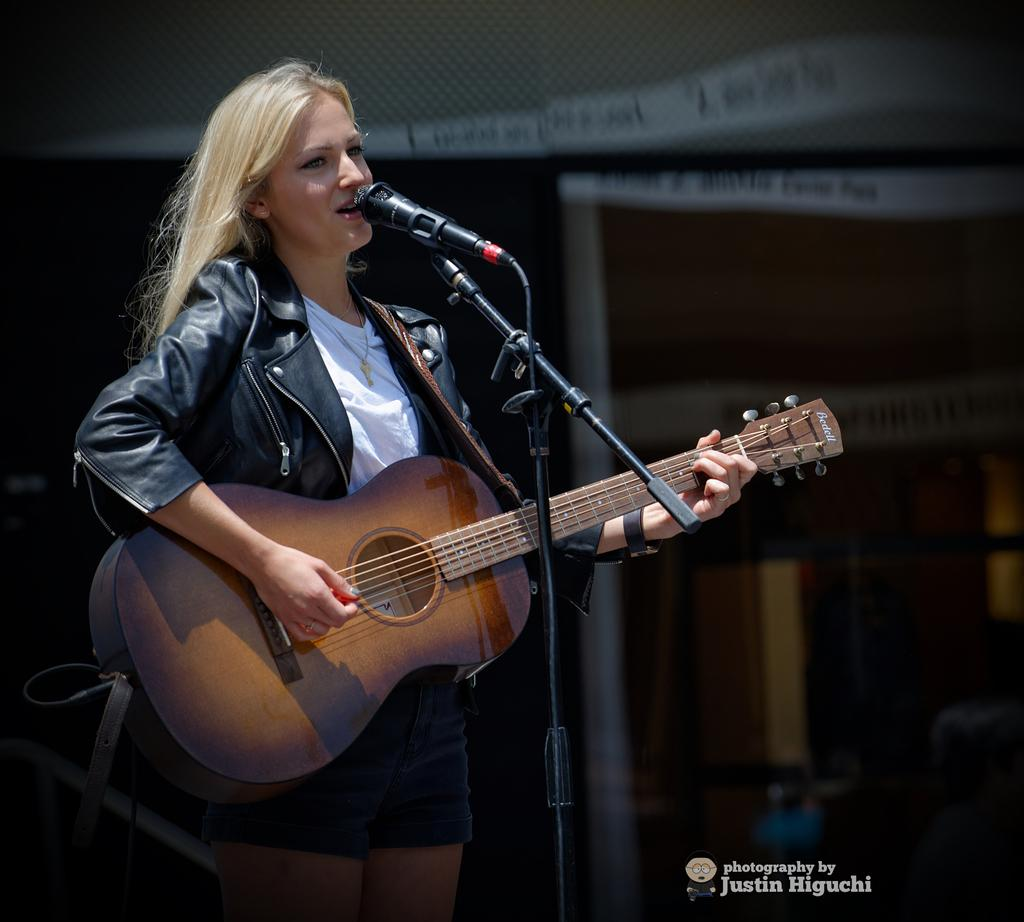Who is the main subject in the image? There is a woman in the image. What is the woman doing in the image? The woman is standing in front of a mic and playing a guitar. What can be seen in the background of the image? There is a sign board in the background of the image. What type of beef is the woman cooking on stage in the image? There is no beef or cooking activity present in the image; the woman is playing a guitar and standing in front of a mic. 